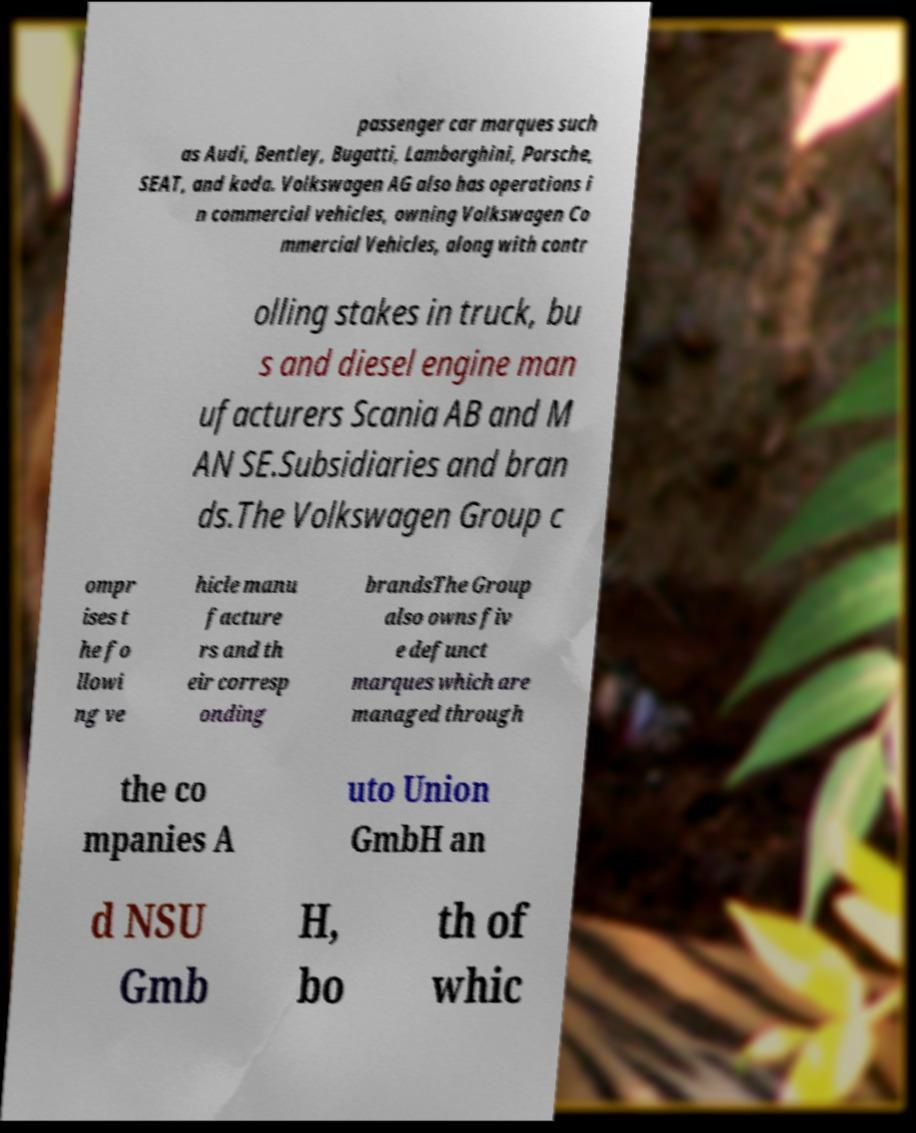Could you extract and type out the text from this image? passenger car marques such as Audi, Bentley, Bugatti, Lamborghini, Porsche, SEAT, and koda. Volkswagen AG also has operations i n commercial vehicles, owning Volkswagen Co mmercial Vehicles, along with contr olling stakes in truck, bu s and diesel engine man ufacturers Scania AB and M AN SE.Subsidiaries and bran ds.The Volkswagen Group c ompr ises t he fo llowi ng ve hicle manu facture rs and th eir corresp onding brandsThe Group also owns fiv e defunct marques which are managed through the co mpanies A uto Union GmbH an d NSU Gmb H, bo th of whic 